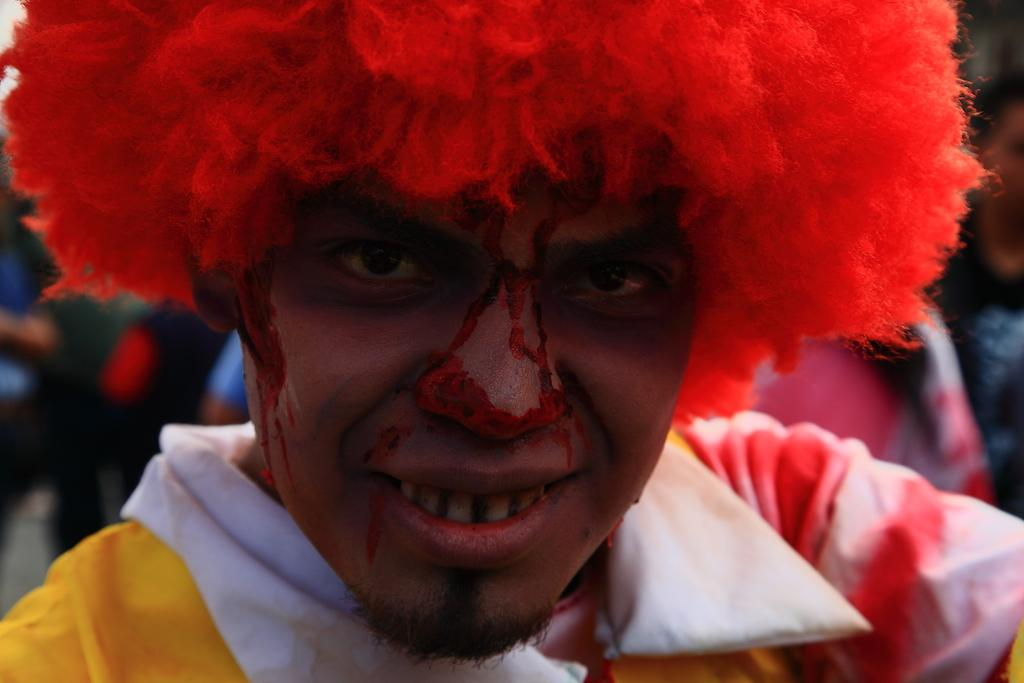Who is the main subject in the image? There is a man in the image. What is the man wearing in the image? The man is wearing a costume in the image. Can you describe the group of people visible in the image? There is a group of people visible on the backside of the man. What type of brush is being used to mix the eggnog in the image? There is no brush or eggnog present in the image. How many hearts can be seen in the image? There are no hearts visible in the image. 